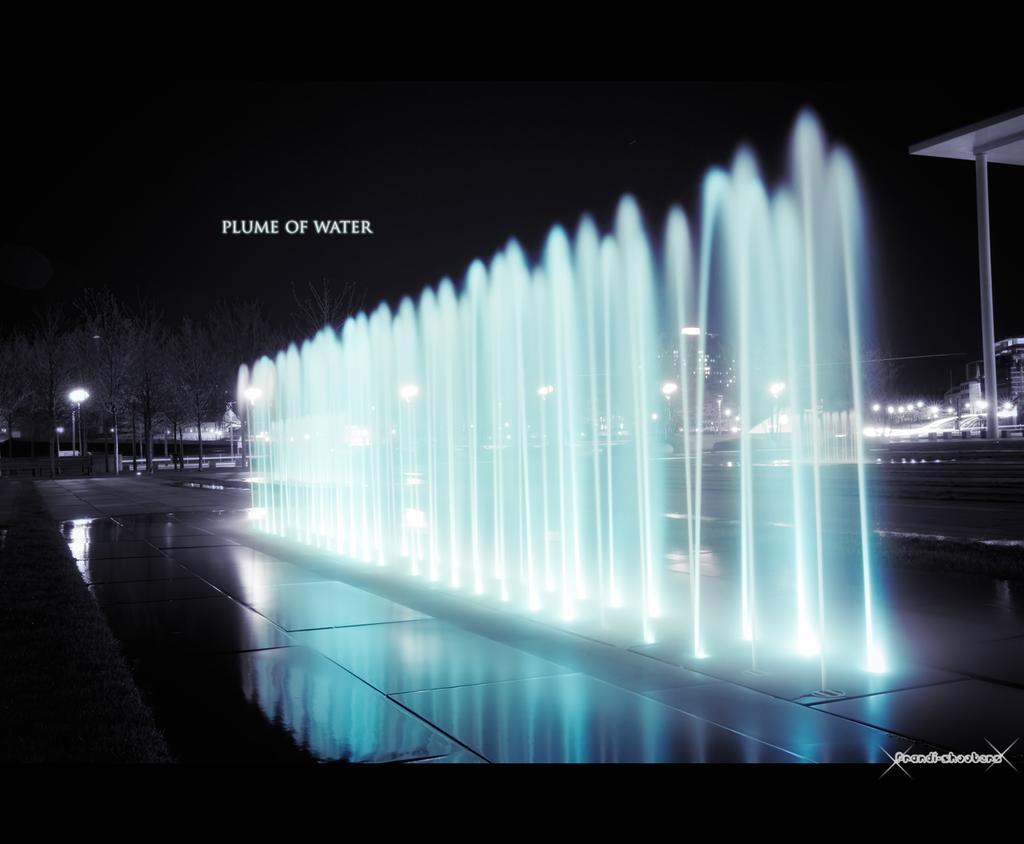Please provide a concise description of this image. This image is taken outdoors. At the top of the image there is the sky. The sky is dark. In the background there are a few poles with street lights. There are a few buildings. At the bottom of the image there is a floor. On the right side of the image there is a roof and there is a pole. There are a few buildings. In the middle of the image there is a fountain with water. 